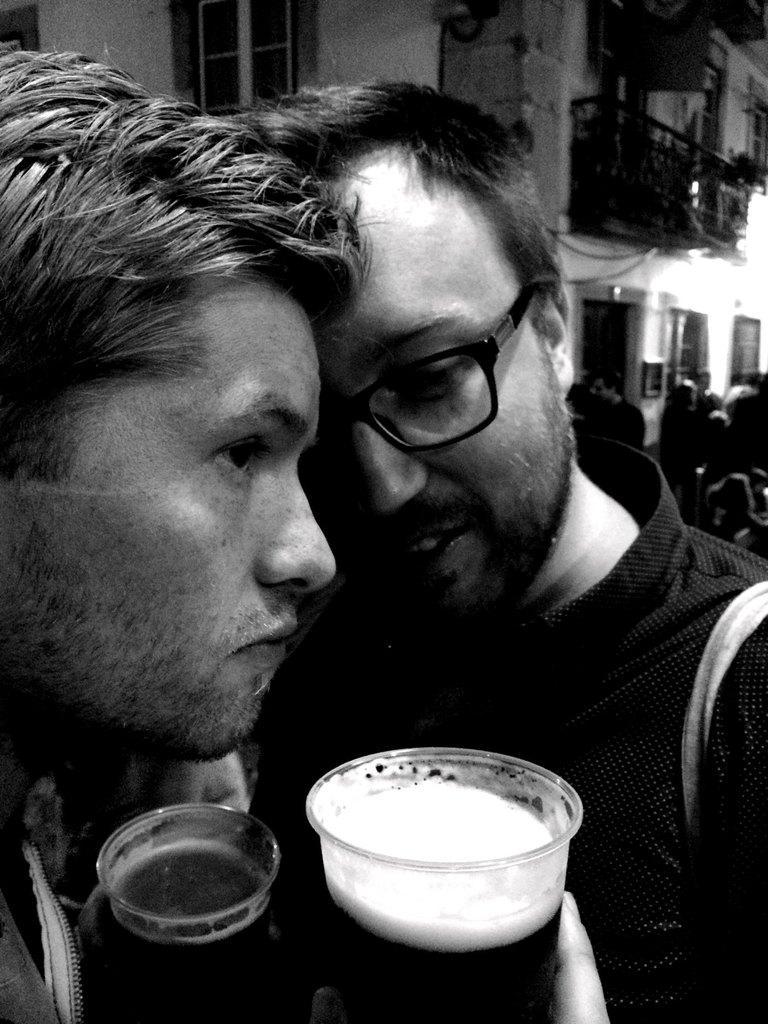Describe this image in one or two sentences. In this picture there are two boys in the center of the image, by holding glasses in their hands and there are other people on the right side of the image. 